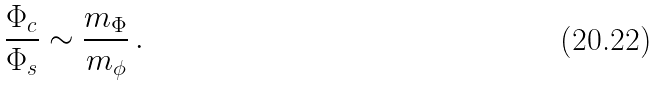Convert formula to latex. <formula><loc_0><loc_0><loc_500><loc_500>\frac { \Phi _ { c } } { \Phi _ { s } } \sim \frac { m _ { \Phi } } { m _ { \phi } } \, .</formula> 